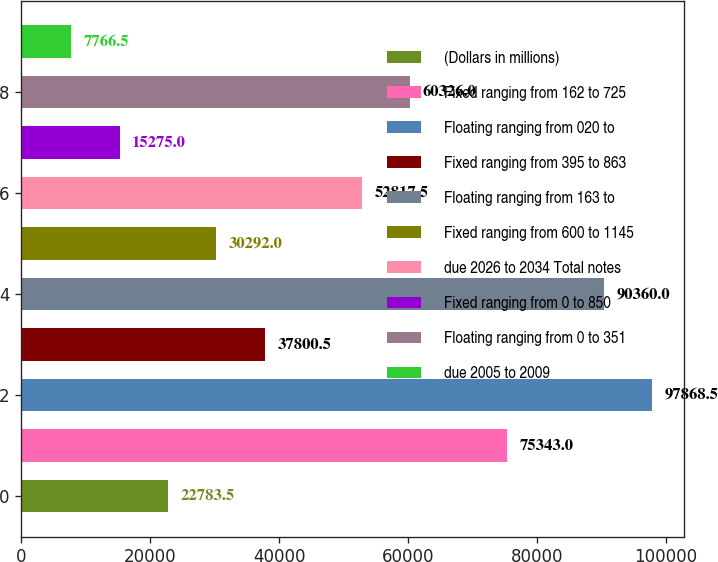Convert chart to OTSL. <chart><loc_0><loc_0><loc_500><loc_500><bar_chart><fcel>(Dollars in millions)<fcel>Fixed ranging from 162 to 725<fcel>Floating ranging from 020 to<fcel>Fixed ranging from 395 to 863<fcel>Floating ranging from 163 to<fcel>Fixed ranging from 600 to 1145<fcel>due 2026 to 2034 Total notes<fcel>Fixed ranging from 0 to 850<fcel>Floating ranging from 0 to 351<fcel>due 2005 to 2009<nl><fcel>22783.5<fcel>75343<fcel>97868.5<fcel>37800.5<fcel>90360<fcel>30292<fcel>52817.5<fcel>15275<fcel>60326<fcel>7766.5<nl></chart> 